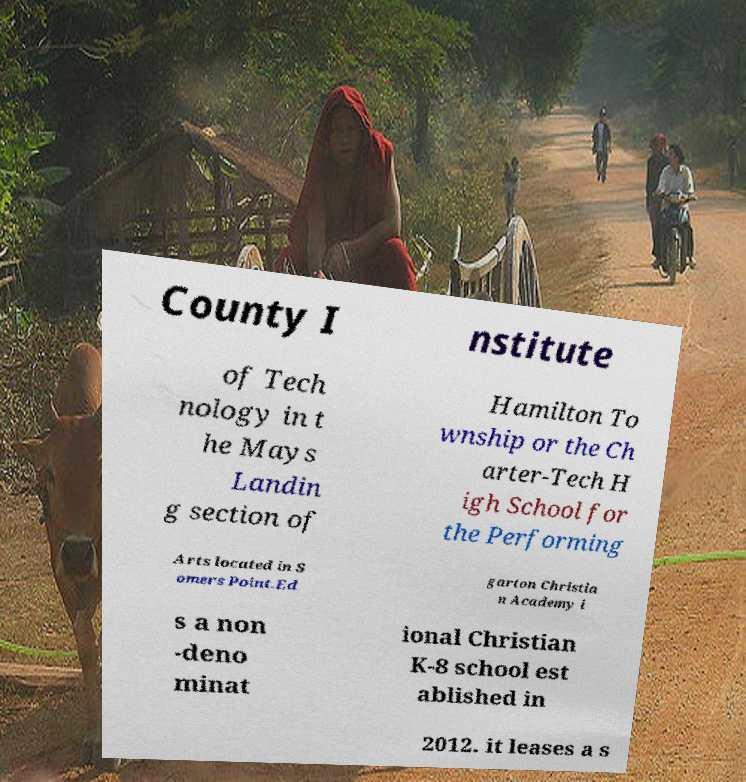What messages or text are displayed in this image? I need them in a readable, typed format. County I nstitute of Tech nology in t he Mays Landin g section of Hamilton To wnship or the Ch arter-Tech H igh School for the Performing Arts located in S omers Point.Ed garton Christia n Academy i s a non -deno minat ional Christian K-8 school est ablished in 2012. it leases a s 